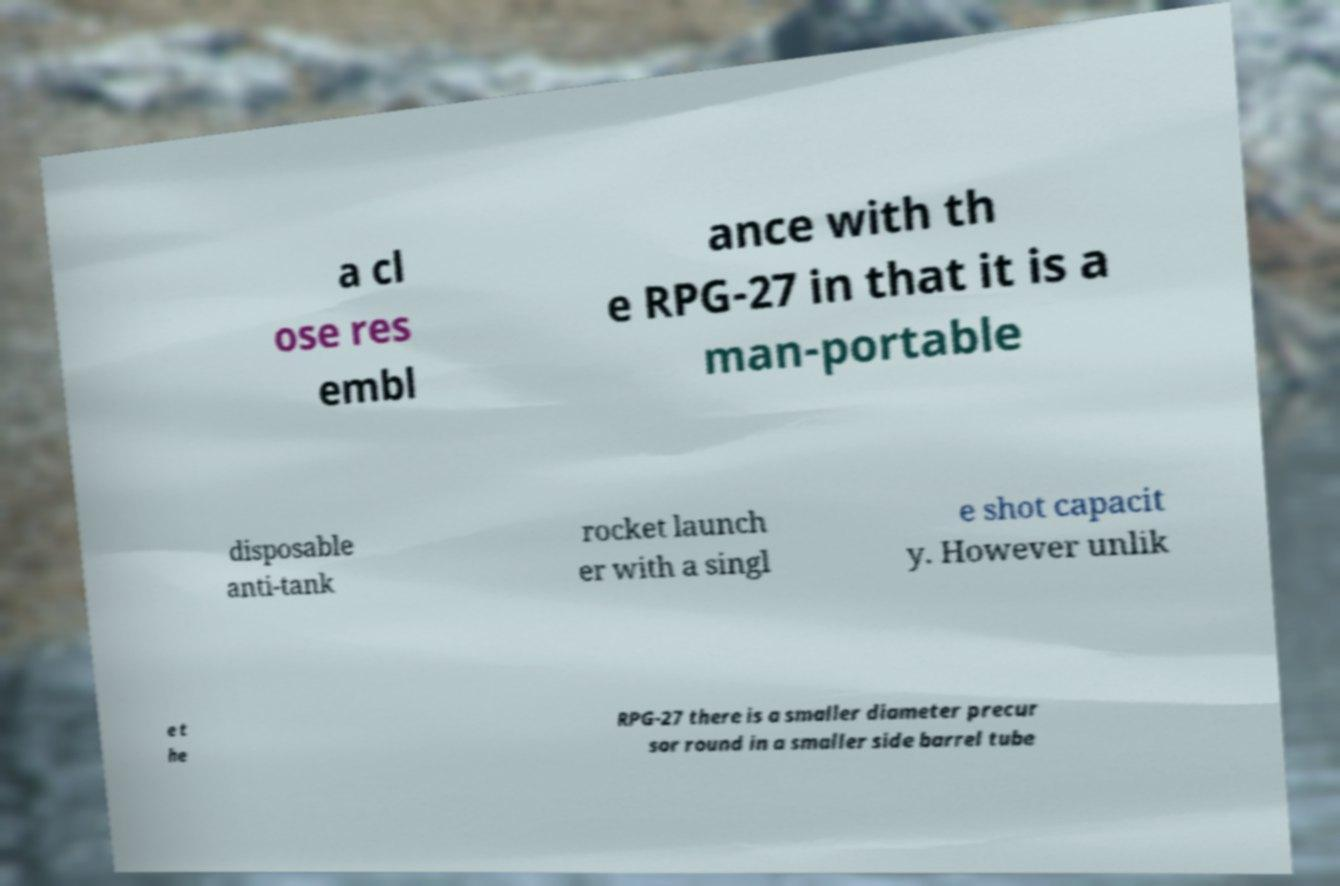Please identify and transcribe the text found in this image. a cl ose res embl ance with th e RPG-27 in that it is a man-portable disposable anti-tank rocket launch er with a singl e shot capacit y. However unlik e t he RPG-27 there is a smaller diameter precur sor round in a smaller side barrel tube 